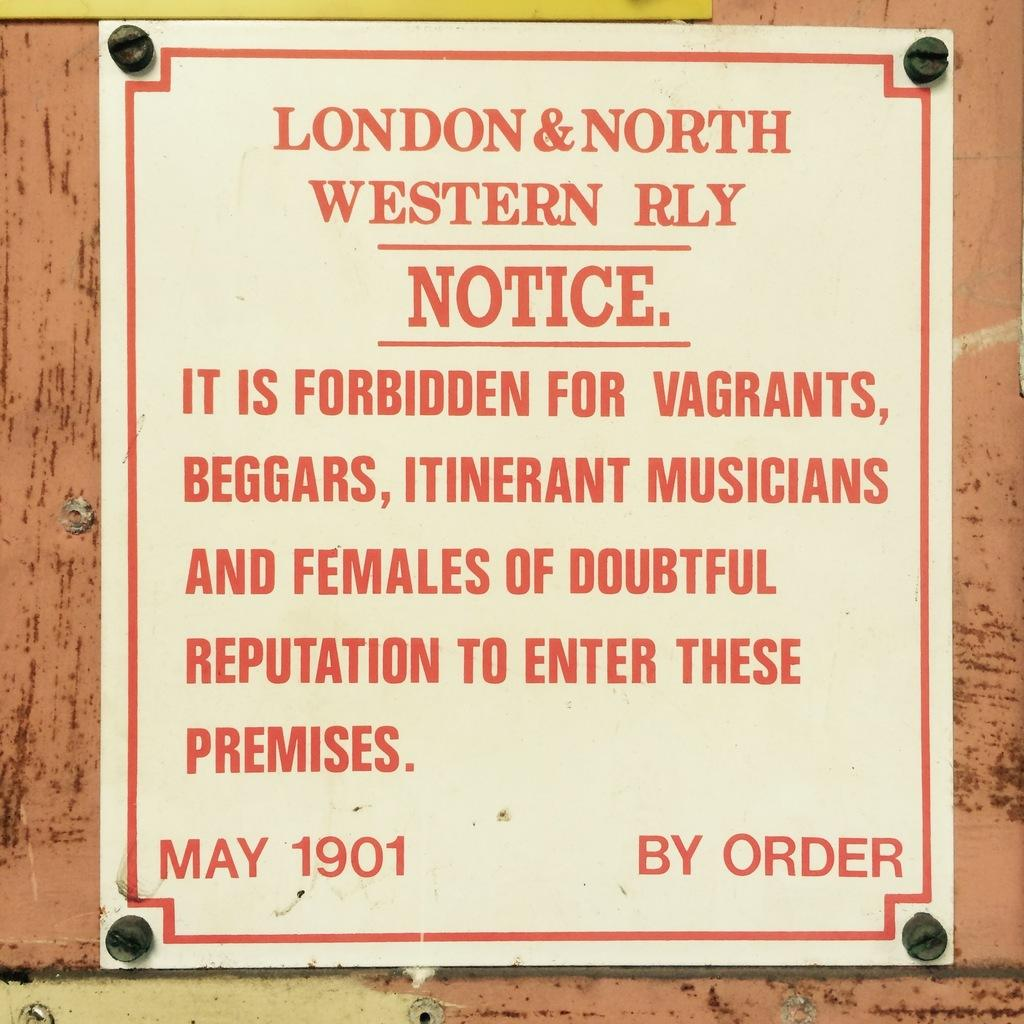<image>
Summarize the visual content of the image. A red and white sign forbids vagrants from entering the premises. 